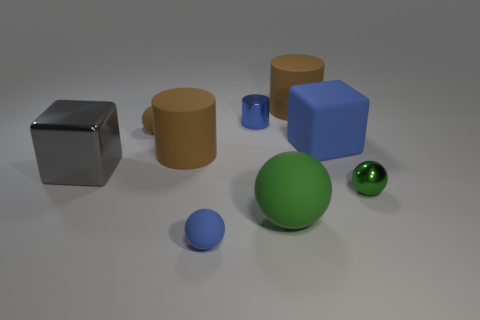Subtract all small green balls. How many balls are left? 3 Add 1 big blue rubber spheres. How many objects exist? 10 Subtract all gray spheres. How many brown cylinders are left? 2 Subtract all green spheres. How many spheres are left? 2 Add 1 metal balls. How many metal balls exist? 2 Subtract 1 blue blocks. How many objects are left? 8 Subtract all balls. How many objects are left? 5 Subtract 2 balls. How many balls are left? 2 Subtract all cyan cylinders. Subtract all gray cubes. How many cylinders are left? 3 Subtract all small brown shiny blocks. Subtract all small blue matte spheres. How many objects are left? 8 